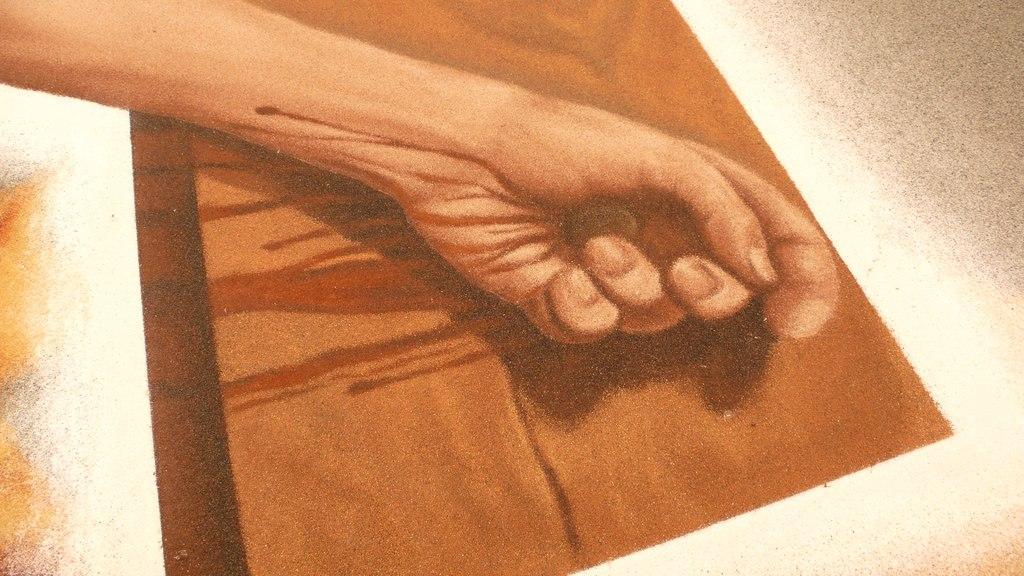Please provide a concise description of this image. In the image there is a hand of a person and there is some object inside the person's hand, there is some object under the hand. 